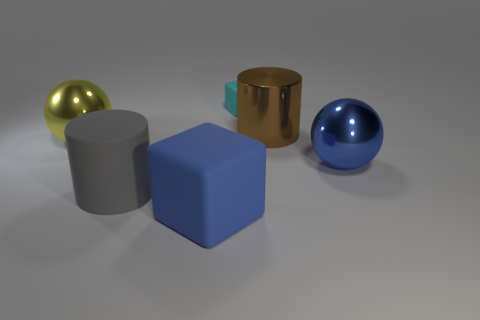How does the texture of the blue object compare to the other objects? The blue object has a smooth and polished texture, which is quite similar to the glossy surfaces of the other objects in the image. The shiny textures suggest they are all made of reflective materials like metals or polished plastics. 